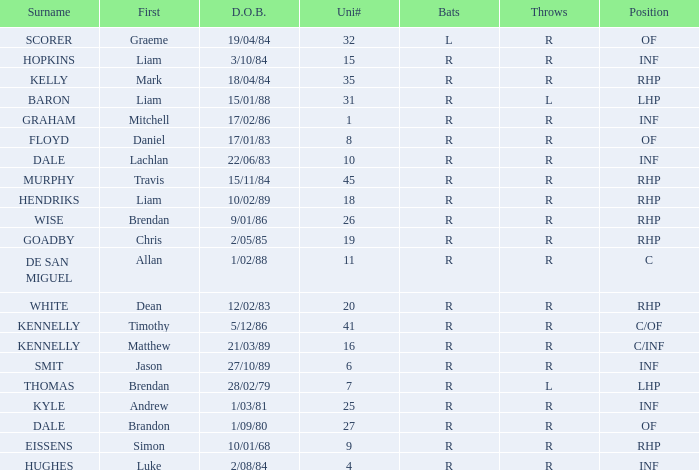Which player has a last name of baron? R. Can you give me this table as a dict? {'header': ['Surname', 'First', 'D.O.B.', 'Uni#', 'Bats', 'Throws', 'Position'], 'rows': [['SCORER', 'Graeme', '19/04/84', '32', 'L', 'R', 'OF'], ['HOPKINS', 'Liam', '3/10/84', '15', 'R', 'R', 'INF'], ['KELLY', 'Mark', '18/04/84', '35', 'R', 'R', 'RHP'], ['BARON', 'Liam', '15/01/88', '31', 'R', 'L', 'LHP'], ['GRAHAM', 'Mitchell', '17/02/86', '1', 'R', 'R', 'INF'], ['FLOYD', 'Daniel', '17/01/83', '8', 'R', 'R', 'OF'], ['DALE', 'Lachlan', '22/06/83', '10', 'R', 'R', 'INF'], ['MURPHY', 'Travis', '15/11/84', '45', 'R', 'R', 'RHP'], ['HENDRIKS', 'Liam', '10/02/89', '18', 'R', 'R', 'RHP'], ['WISE', 'Brendan', '9/01/86', '26', 'R', 'R', 'RHP'], ['GOADBY', 'Chris', '2/05/85', '19', 'R', 'R', 'RHP'], ['DE SAN MIGUEL', 'Allan', '1/02/88', '11', 'R', 'R', 'C'], ['WHITE', 'Dean', '12/02/83', '20', 'R', 'R', 'RHP'], ['KENNELLY', 'Timothy', '5/12/86', '41', 'R', 'R', 'C/OF'], ['KENNELLY', 'Matthew', '21/03/89', '16', 'R', 'R', 'C/INF'], ['SMIT', 'Jason', '27/10/89', '6', 'R', 'R', 'INF'], ['THOMAS', 'Brendan', '28/02/79', '7', 'R', 'L', 'LHP'], ['KYLE', 'Andrew', '1/03/81', '25', 'R', 'R', 'INF'], ['DALE', 'Brandon', '1/09/80', '27', 'R', 'R', 'OF'], ['EISSENS', 'Simon', '10/01/68', '9', 'R', 'R', 'RHP'], ['HUGHES', 'Luke', '2/08/84', '4', 'R', 'R', 'INF']]} 